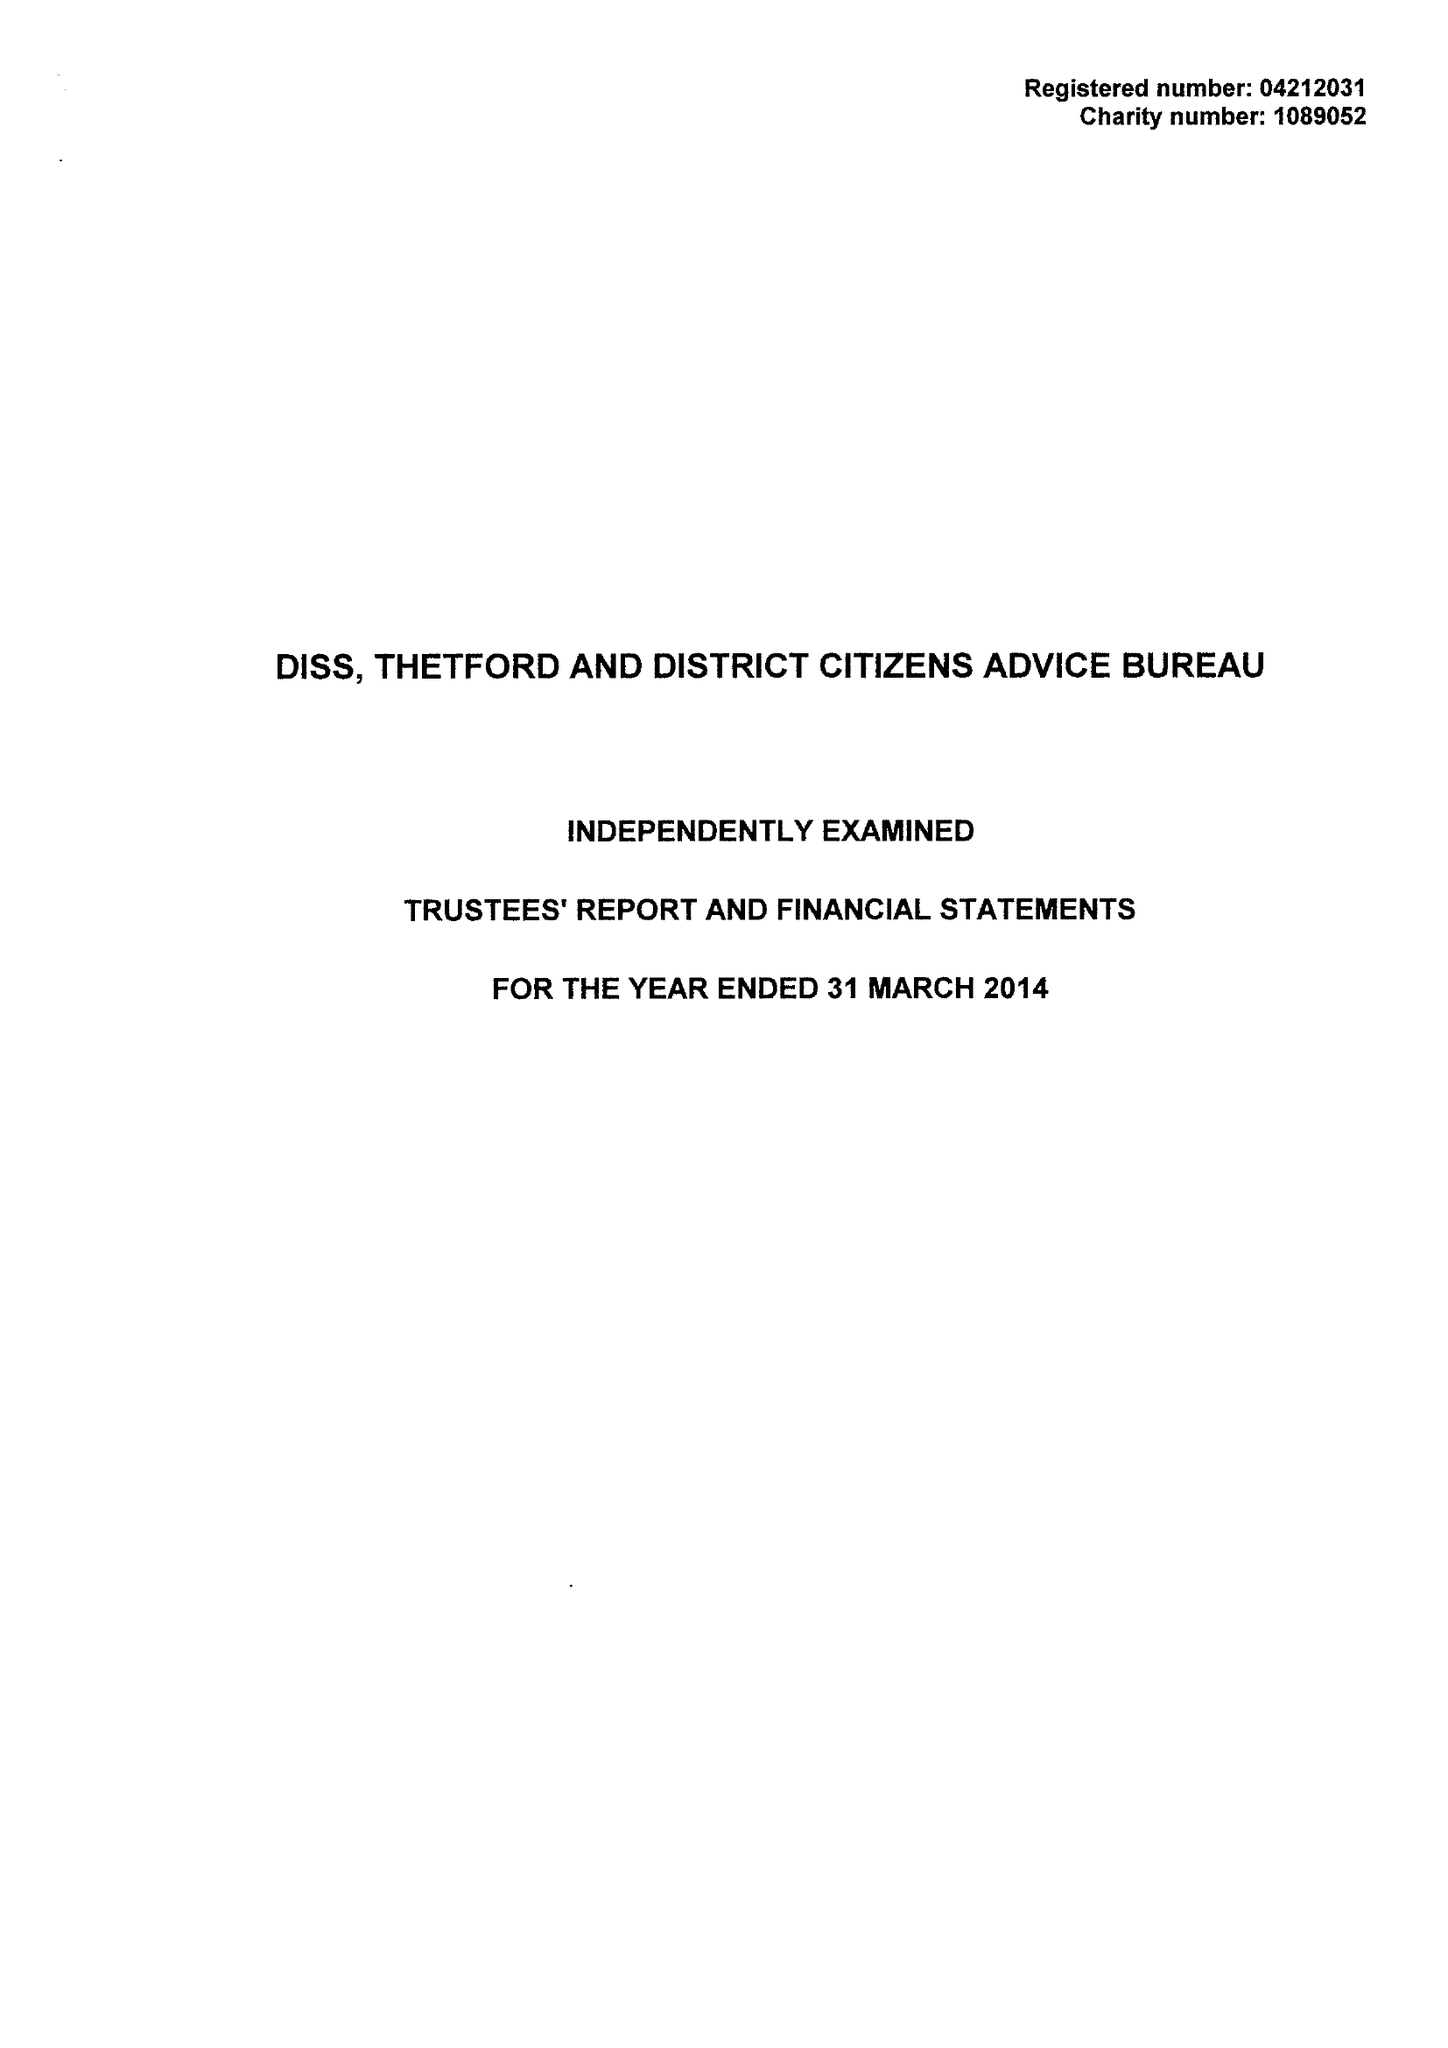What is the value for the charity_number?
Answer the question using a single word or phrase. 1089052 